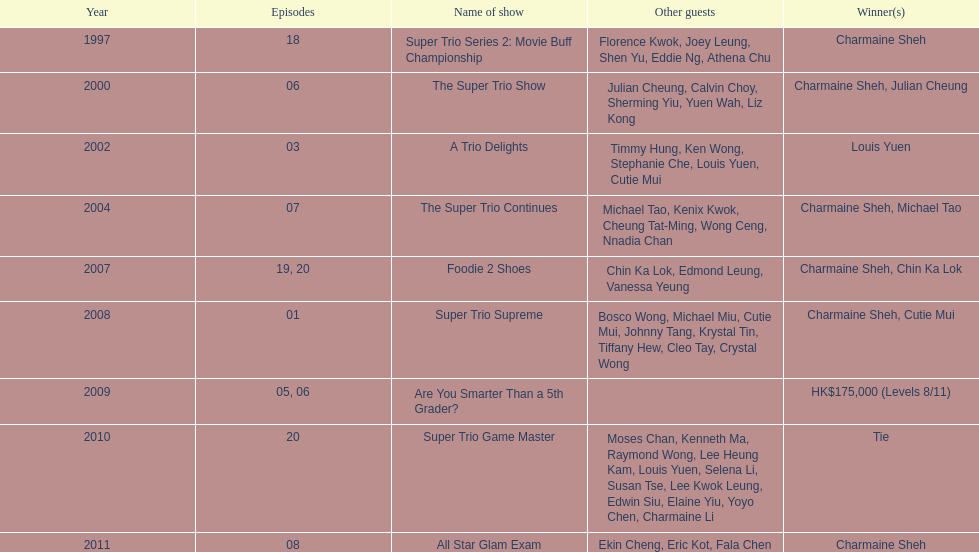How many of shows had at least 5 episodes? 7. 